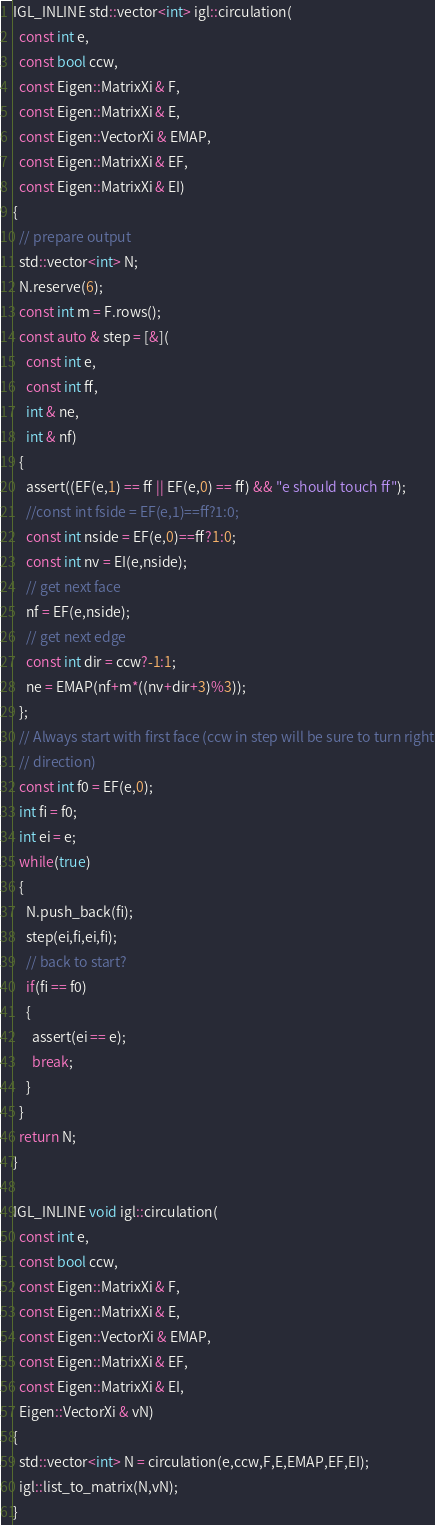<code> <loc_0><loc_0><loc_500><loc_500><_C++_>IGL_INLINE std::vector<int> igl::circulation(
  const int e,
  const bool ccw,
  const Eigen::MatrixXi & F,
  const Eigen::MatrixXi & E,
  const Eigen::VectorXi & EMAP,
  const Eigen::MatrixXi & EF,
  const Eigen::MatrixXi & EI)
{
  // prepare output
  std::vector<int> N;
  N.reserve(6);
  const int m = F.rows();
  const auto & step = [&](
    const int e, 
    const int ff,
    int & ne, 
    int & nf)
  {
    assert((EF(e,1) == ff || EF(e,0) == ff) && "e should touch ff");
    //const int fside = EF(e,1)==ff?1:0;
    const int nside = EF(e,0)==ff?1:0;
    const int nv = EI(e,nside);
    // get next face
    nf = EF(e,nside);
    // get next edge 
    const int dir = ccw?-1:1;
    ne = EMAP(nf+m*((nv+dir+3)%3));
  };
  // Always start with first face (ccw in step will be sure to turn right
  // direction)
  const int f0 = EF(e,0);
  int fi = f0;
  int ei = e;
  while(true)
  {
    N.push_back(fi);
    step(ei,fi,ei,fi);
    // back to start?
    if(fi == f0)
    {
      assert(ei == e);
      break;
    }
  }
  return N;
}

IGL_INLINE void igl::circulation(
  const int e,
  const bool ccw,
  const Eigen::MatrixXi & F,
  const Eigen::MatrixXi & E,
  const Eigen::VectorXi & EMAP,
  const Eigen::MatrixXi & EF,
  const Eigen::MatrixXi & EI,
  Eigen::VectorXi & vN)
{
  std::vector<int> N = circulation(e,ccw,F,E,EMAP,EF,EI);
  igl::list_to_matrix(N,vN);
}
</code> 